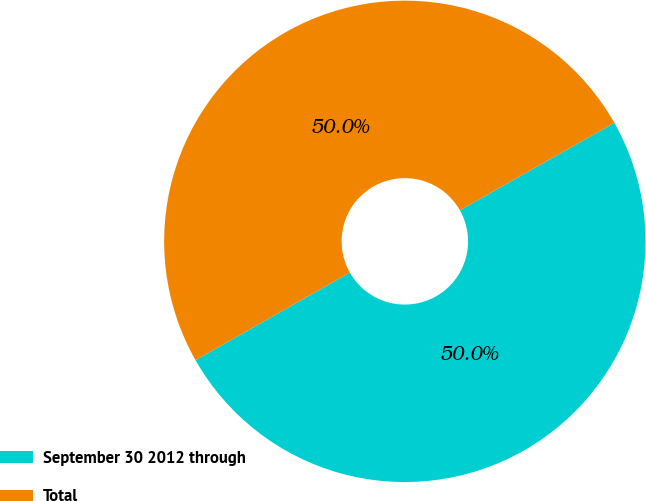<chart> <loc_0><loc_0><loc_500><loc_500><pie_chart><fcel>September 30 2012 through<fcel>Total<nl><fcel>49.98%<fcel>50.02%<nl></chart> 